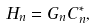Convert formula to latex. <formula><loc_0><loc_0><loc_500><loc_500>H _ { n } & = G _ { n } C _ { n } ^ { * } ,</formula> 